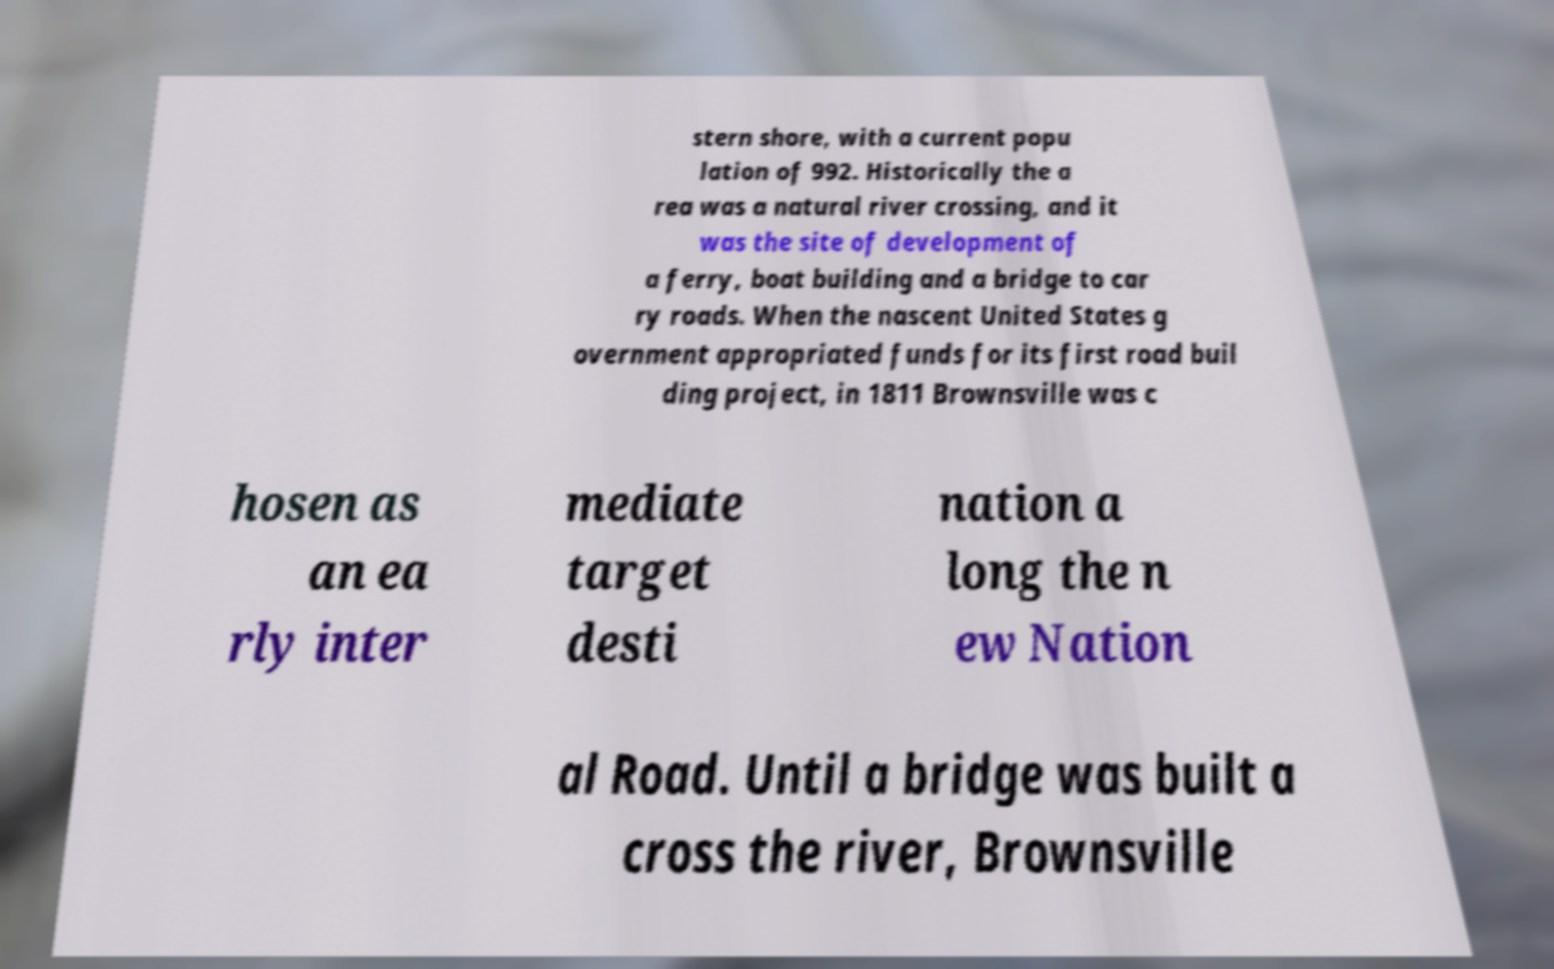Please identify and transcribe the text found in this image. stern shore, with a current popu lation of 992. Historically the a rea was a natural river crossing, and it was the site of development of a ferry, boat building and a bridge to car ry roads. When the nascent United States g overnment appropriated funds for its first road buil ding project, in 1811 Brownsville was c hosen as an ea rly inter mediate target desti nation a long the n ew Nation al Road. Until a bridge was built a cross the river, Brownsville 